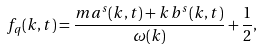Convert formula to latex. <formula><loc_0><loc_0><loc_500><loc_500>f _ { q } ( k , t ) = \frac { m a ^ { s } ( k , t ) + k \, b ^ { s } ( k , t ) } { \omega ( k ) } + \frac { 1 } { 2 } ,</formula> 